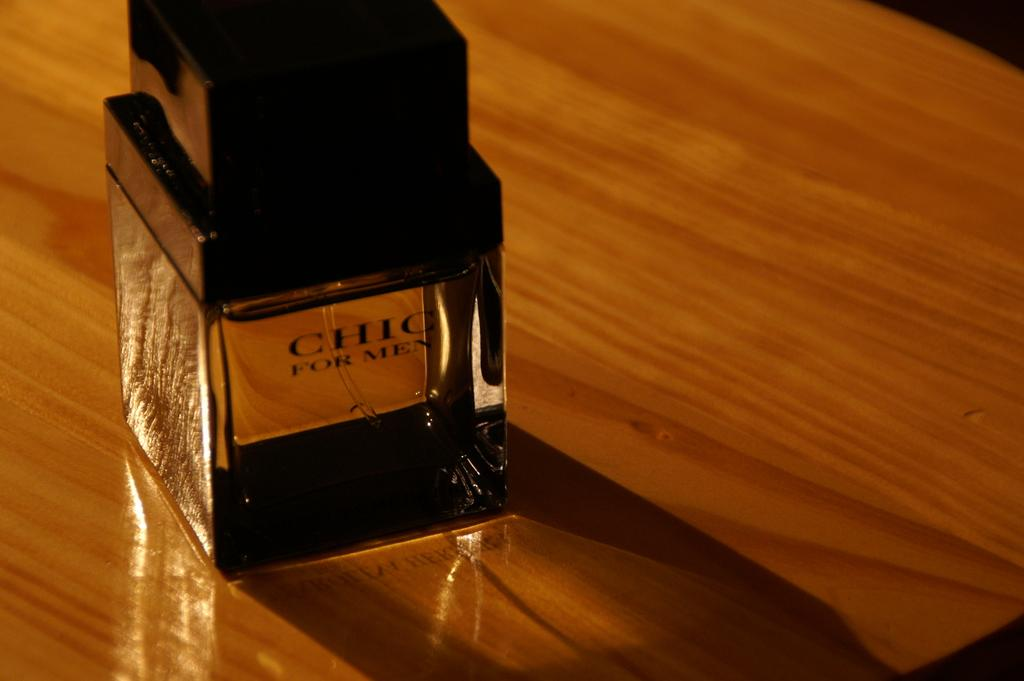<image>
Relay a brief, clear account of the picture shown. On a highly polished wooden table sits a bottle of Chic For Men. 